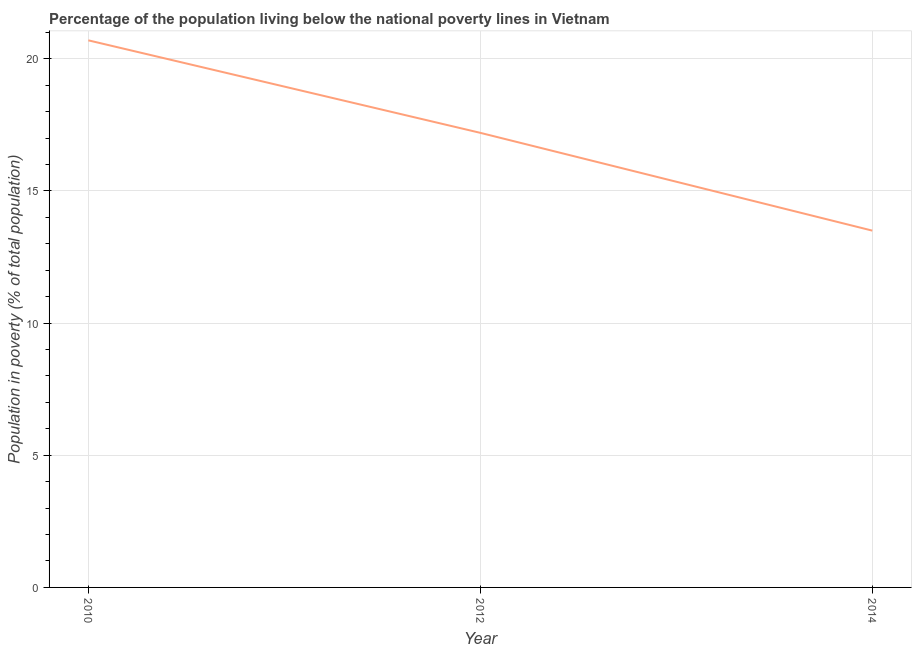What is the percentage of population living below poverty line in 2010?
Your answer should be very brief. 20.7. Across all years, what is the maximum percentage of population living below poverty line?
Provide a short and direct response. 20.7. Across all years, what is the minimum percentage of population living below poverty line?
Your response must be concise. 13.5. In which year was the percentage of population living below poverty line minimum?
Keep it short and to the point. 2014. What is the sum of the percentage of population living below poverty line?
Ensure brevity in your answer.  51.4. What is the average percentage of population living below poverty line per year?
Offer a very short reply. 17.13. Do a majority of the years between 2010 and 2014 (inclusive) have percentage of population living below poverty line greater than 16 %?
Provide a succinct answer. Yes. What is the ratio of the percentage of population living below poverty line in 2010 to that in 2012?
Provide a short and direct response. 1.2. Is the sum of the percentage of population living below poverty line in 2012 and 2014 greater than the maximum percentage of population living below poverty line across all years?
Your response must be concise. Yes. What is the difference between the highest and the lowest percentage of population living below poverty line?
Ensure brevity in your answer.  7.2. Does the percentage of population living below poverty line monotonically increase over the years?
Your response must be concise. No. How many years are there in the graph?
Make the answer very short. 3. Does the graph contain any zero values?
Provide a short and direct response. No. What is the title of the graph?
Provide a succinct answer. Percentage of the population living below the national poverty lines in Vietnam. What is the label or title of the X-axis?
Give a very brief answer. Year. What is the label or title of the Y-axis?
Give a very brief answer. Population in poverty (% of total population). What is the Population in poverty (% of total population) in 2010?
Ensure brevity in your answer.  20.7. What is the Population in poverty (% of total population) of 2012?
Ensure brevity in your answer.  17.2. What is the Population in poverty (% of total population) in 2014?
Keep it short and to the point. 13.5. What is the difference between the Population in poverty (% of total population) in 2010 and 2012?
Your answer should be compact. 3.5. What is the difference between the Population in poverty (% of total population) in 2010 and 2014?
Offer a terse response. 7.2. What is the difference between the Population in poverty (% of total population) in 2012 and 2014?
Your response must be concise. 3.7. What is the ratio of the Population in poverty (% of total population) in 2010 to that in 2012?
Provide a short and direct response. 1.2. What is the ratio of the Population in poverty (% of total population) in 2010 to that in 2014?
Make the answer very short. 1.53. What is the ratio of the Population in poverty (% of total population) in 2012 to that in 2014?
Your answer should be compact. 1.27. 